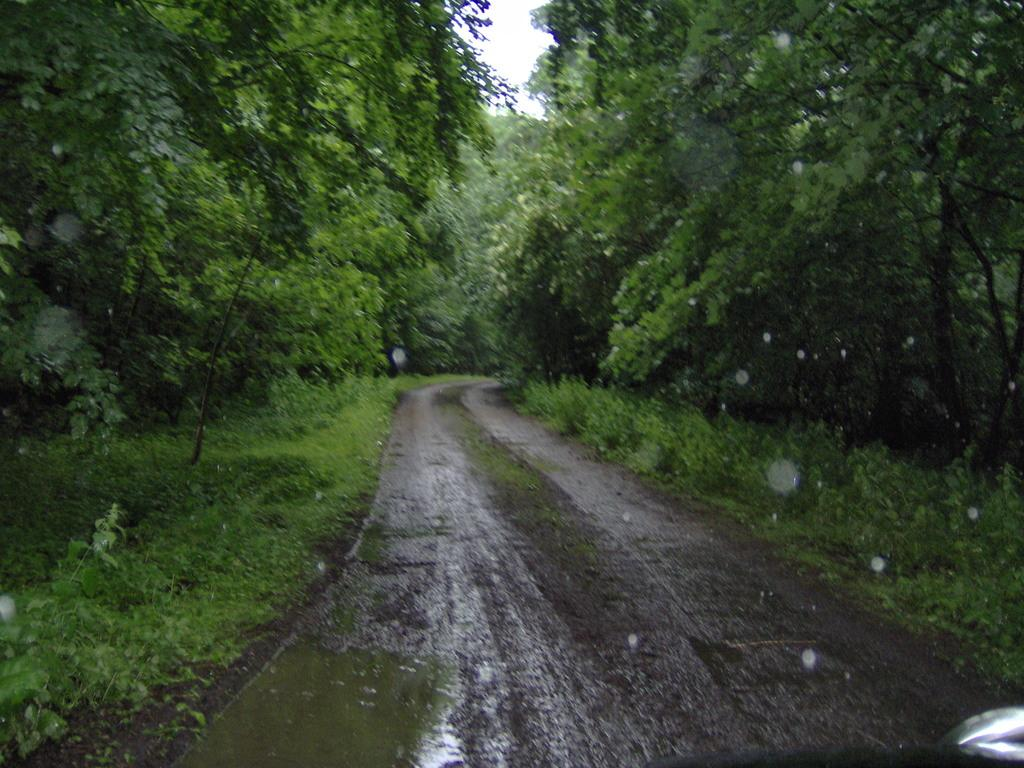What is the main feature of the image? There is a road in the image. What else can be seen besides the road? Water is visible in the image, and there is a group of plants and trees beside the road. What is visible at the top of the image? The sky is visible at the top of the image. What type of oatmeal is being used to draw on the road in the image? There is no oatmeal present in the image, and it is not being used to draw on the road. 